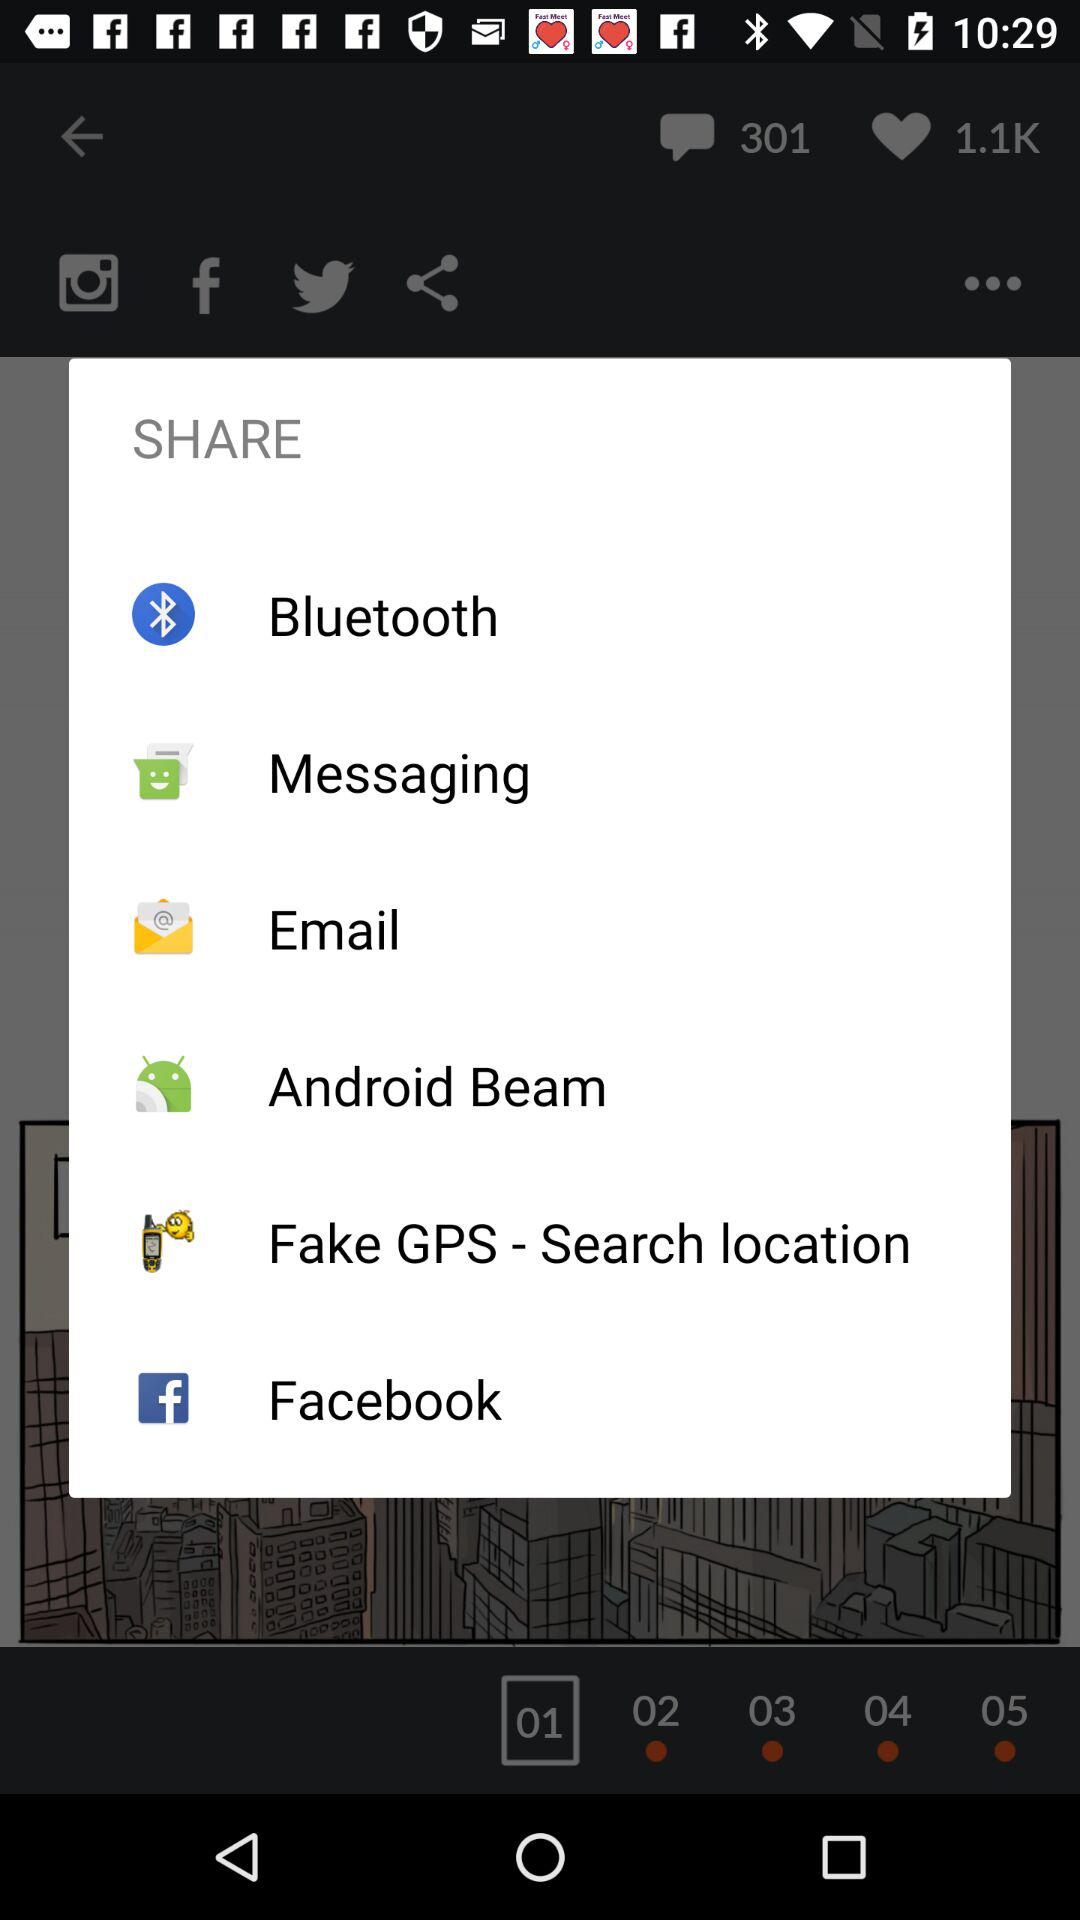How many items are in the share menu?
Answer the question using a single word or phrase. 6 